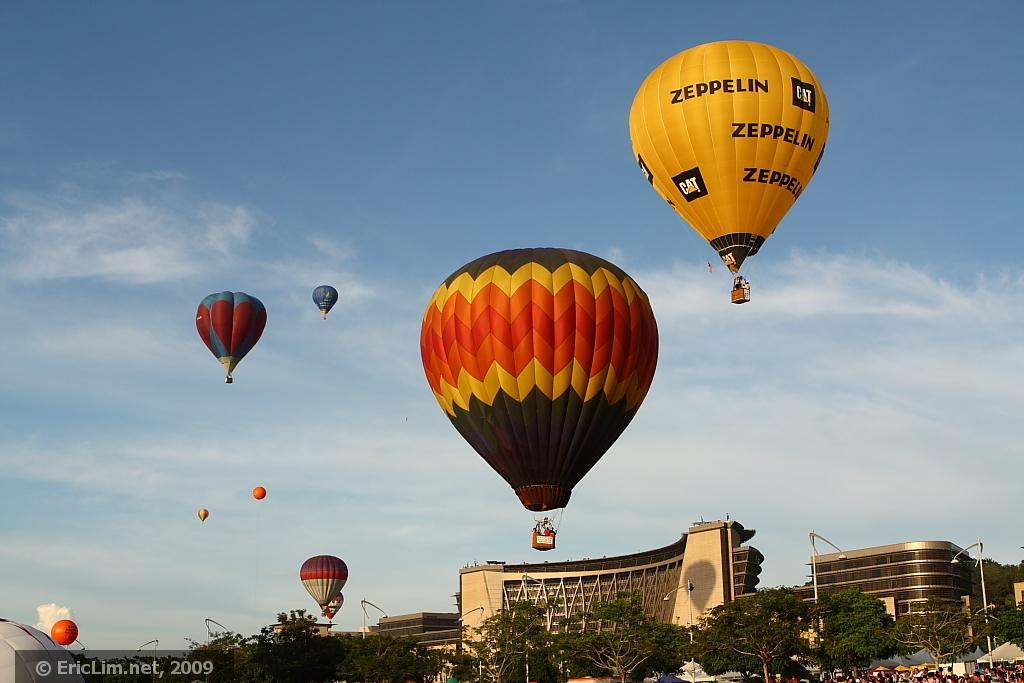Provide a one-sentence caption for the provided image. Many multi colored hot air balloons float about the city, one of them displaying ads for Zeppelin and CAT construction on them. 